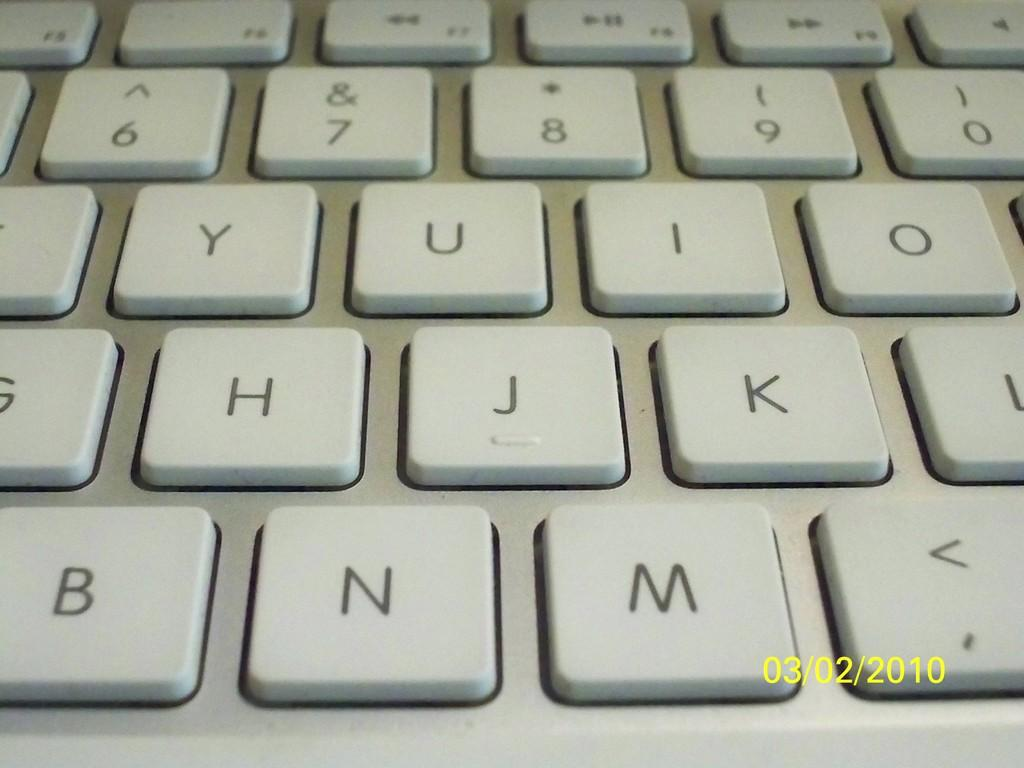<image>
Summarize the visual content of the image. The center part of a keyboard was photographed on 03/02/2010. 